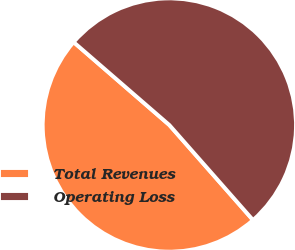Convert chart. <chart><loc_0><loc_0><loc_500><loc_500><pie_chart><fcel>Total Revenues<fcel>Operating Loss<nl><fcel>47.85%<fcel>52.15%<nl></chart> 